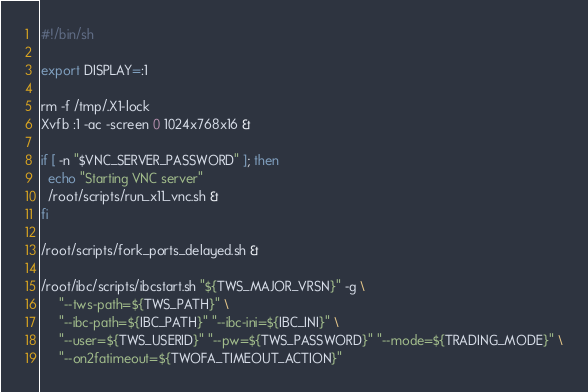<code> <loc_0><loc_0><loc_500><loc_500><_Bash_>#!/bin/sh

export DISPLAY=:1

rm -f /tmp/.X1-lock
Xvfb :1 -ac -screen 0 1024x768x16 &

if [ -n "$VNC_SERVER_PASSWORD" ]; then
  echo "Starting VNC server"
  /root/scripts/run_x11_vnc.sh &
fi

/root/scripts/fork_ports_delayed.sh &

/root/ibc/scripts/ibcstart.sh "${TWS_MAJOR_VRSN}" -g \
     "--tws-path=${TWS_PATH}" \
     "--ibc-path=${IBC_PATH}" "--ibc-ini=${IBC_INI}" \
     "--user=${TWS_USERID}" "--pw=${TWS_PASSWORD}" "--mode=${TRADING_MODE}" \
     "--on2fatimeout=${TWOFA_TIMEOUT_ACTION}"
</code> 